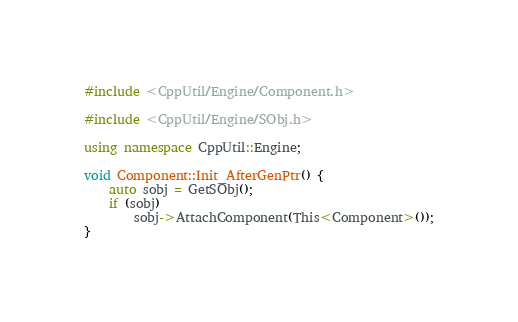<code> <loc_0><loc_0><loc_500><loc_500><_C++_>#include <CppUtil/Engine/Component.h>

#include <CppUtil/Engine/SObj.h>

using namespace CppUtil::Engine;

void Component::Init_AfterGenPtr() {
	auto sobj = GetSObj();
	if (sobj)
		sobj->AttachComponent(This<Component>());
}
</code> 